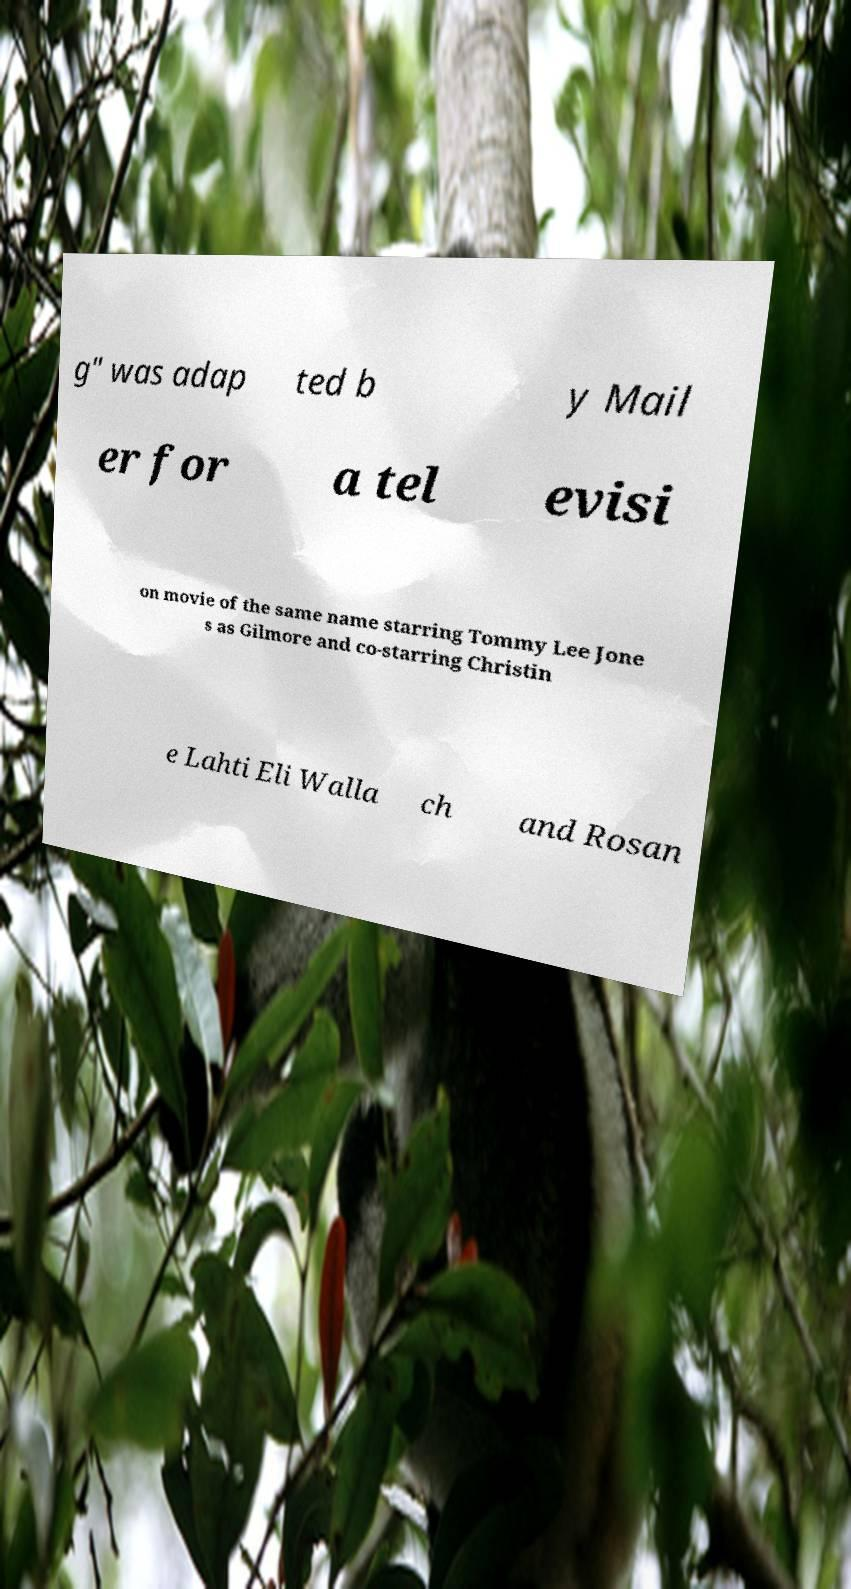What messages or text are displayed in this image? I need them in a readable, typed format. g" was adap ted b y Mail er for a tel evisi on movie of the same name starring Tommy Lee Jone s as Gilmore and co-starring Christin e Lahti Eli Walla ch and Rosan 